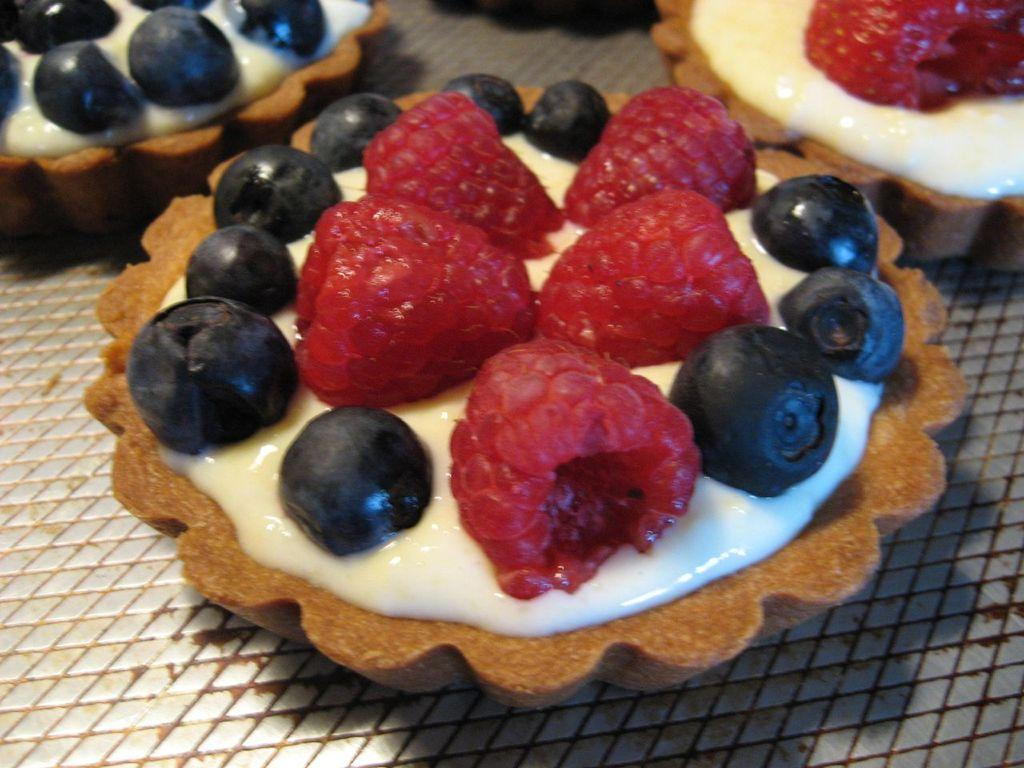What type of food items are visible in the image? The food items resemble cookies. Where are the cookies located in the image? The cookies are on a plate. What type of laborer is depicted working on the cookies in the image? There is no laborer present in the image, and the cookies are not being worked on. What type of rake is used to mix the cookie dough in the image? There is no rake present in the image, and the cookies are already baked and on a plate. 